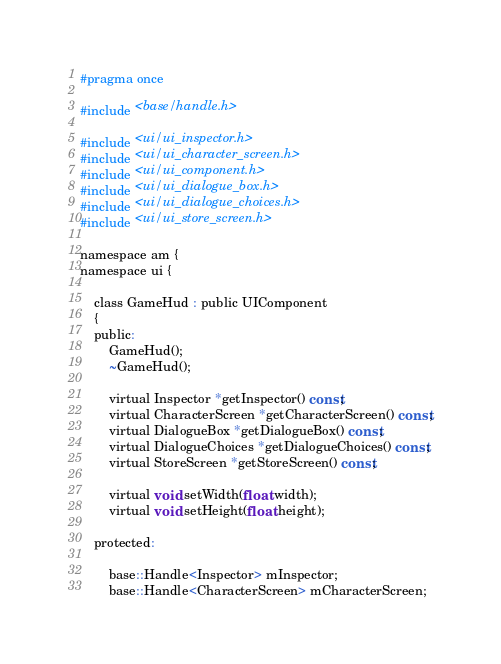<code> <loc_0><loc_0><loc_500><loc_500><_C_>#pragma once

#include <base/handle.h>

#include <ui/ui_inspector.h>
#include <ui/ui_character_screen.h>
#include <ui/ui_component.h>
#include <ui/ui_dialogue_box.h>
#include <ui/ui_dialogue_choices.h>
#include <ui/ui_store_screen.h>

namespace am {
namespace ui {

	class GameHud : public UIComponent 
	{
	public:
		GameHud();
		~GameHud();

		virtual Inspector *getInspector() const;
		virtual CharacterScreen *getCharacterScreen() const;
		virtual DialogueBox *getDialogueBox() const;
		virtual DialogueChoices *getDialogueChoices() const;
		virtual StoreScreen *getStoreScreen() const;

		virtual void setWidth(float width);
		virtual void setHeight(float height);

	protected:

		base::Handle<Inspector> mInspector;
		base::Handle<CharacterScreen> mCharacterScreen;</code> 